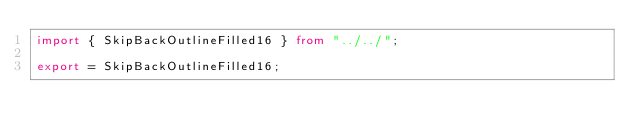<code> <loc_0><loc_0><loc_500><loc_500><_TypeScript_>import { SkipBackOutlineFilled16 } from "../../";

export = SkipBackOutlineFilled16;
</code> 